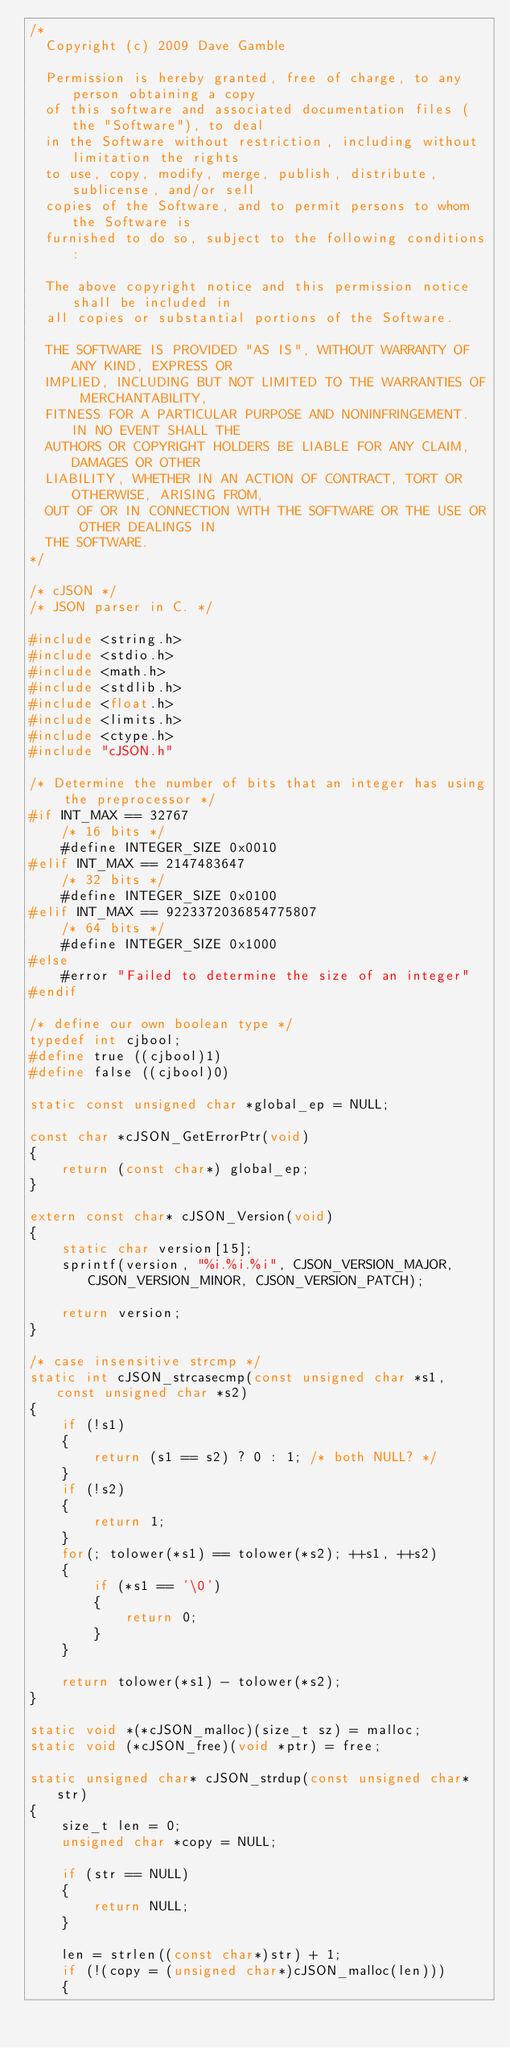<code> <loc_0><loc_0><loc_500><loc_500><_C_>/*
  Copyright (c) 2009 Dave Gamble

  Permission is hereby granted, free of charge, to any person obtaining a copy
  of this software and associated documentation files (the "Software"), to deal
  in the Software without restriction, including without limitation the rights
  to use, copy, modify, merge, publish, distribute, sublicense, and/or sell
  copies of the Software, and to permit persons to whom the Software is
  furnished to do so, subject to the following conditions:

  The above copyright notice and this permission notice shall be included in
  all copies or substantial portions of the Software.

  THE SOFTWARE IS PROVIDED "AS IS", WITHOUT WARRANTY OF ANY KIND, EXPRESS OR
  IMPLIED, INCLUDING BUT NOT LIMITED TO THE WARRANTIES OF MERCHANTABILITY,
  FITNESS FOR A PARTICULAR PURPOSE AND NONINFRINGEMENT. IN NO EVENT SHALL THE
  AUTHORS OR COPYRIGHT HOLDERS BE LIABLE FOR ANY CLAIM, DAMAGES OR OTHER
  LIABILITY, WHETHER IN AN ACTION OF CONTRACT, TORT OR OTHERWISE, ARISING FROM,
  OUT OF OR IN CONNECTION WITH THE SOFTWARE OR THE USE OR OTHER DEALINGS IN
  THE SOFTWARE.
*/

/* cJSON */
/* JSON parser in C. */

#include <string.h>
#include <stdio.h>
#include <math.h>
#include <stdlib.h>
#include <float.h>
#include <limits.h>
#include <ctype.h>
#include "cJSON.h"

/* Determine the number of bits that an integer has using the preprocessor */
#if INT_MAX == 32767
    /* 16 bits */
    #define INTEGER_SIZE 0x0010
#elif INT_MAX == 2147483647
    /* 32 bits */
    #define INTEGER_SIZE 0x0100
#elif INT_MAX == 9223372036854775807
    /* 64 bits */
    #define INTEGER_SIZE 0x1000
#else
    #error "Failed to determine the size of an integer"
#endif

/* define our own boolean type */
typedef int cjbool;
#define true ((cjbool)1)
#define false ((cjbool)0)

static const unsigned char *global_ep = NULL;

const char *cJSON_GetErrorPtr(void)
{
    return (const char*) global_ep;
}

extern const char* cJSON_Version(void)
{
    static char version[15];
    sprintf(version, "%i.%i.%i", CJSON_VERSION_MAJOR, CJSON_VERSION_MINOR, CJSON_VERSION_PATCH);

    return version;
}

/* case insensitive strcmp */
static int cJSON_strcasecmp(const unsigned char *s1, const unsigned char *s2)
{
    if (!s1)
    {
        return (s1 == s2) ? 0 : 1; /* both NULL? */
    }
    if (!s2)
    {
        return 1;
    }
    for(; tolower(*s1) == tolower(*s2); ++s1, ++s2)
    {
        if (*s1 == '\0')
        {
            return 0;
        }
    }

    return tolower(*s1) - tolower(*s2);
}

static void *(*cJSON_malloc)(size_t sz) = malloc;
static void (*cJSON_free)(void *ptr) = free;

static unsigned char* cJSON_strdup(const unsigned char* str)
{
    size_t len = 0;
    unsigned char *copy = NULL;

    if (str == NULL)
    {
        return NULL;
    }

    len = strlen((const char*)str) + 1;
    if (!(copy = (unsigned char*)cJSON_malloc(len)))
    {</code> 